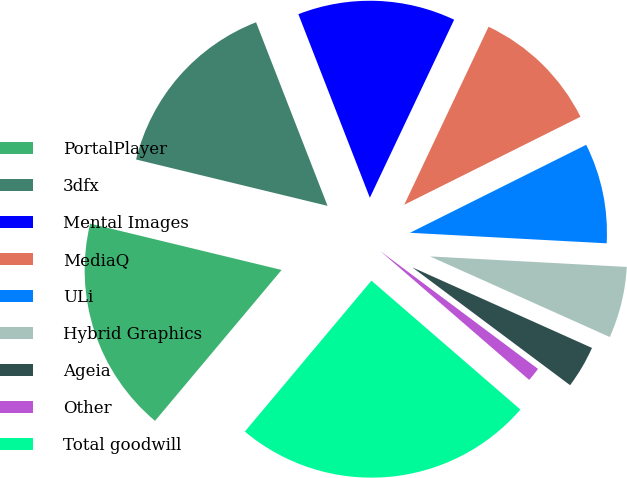<chart> <loc_0><loc_0><loc_500><loc_500><pie_chart><fcel>PortalPlayer<fcel>3dfx<fcel>Mental Images<fcel>MediaQ<fcel>ULi<fcel>Hybrid Graphics<fcel>Ageia<fcel>Other<fcel>Total goodwill<nl><fcel>17.67%<fcel>15.31%<fcel>12.95%<fcel>10.59%<fcel>8.22%<fcel>5.86%<fcel>3.5%<fcel>1.14%<fcel>24.76%<nl></chart> 